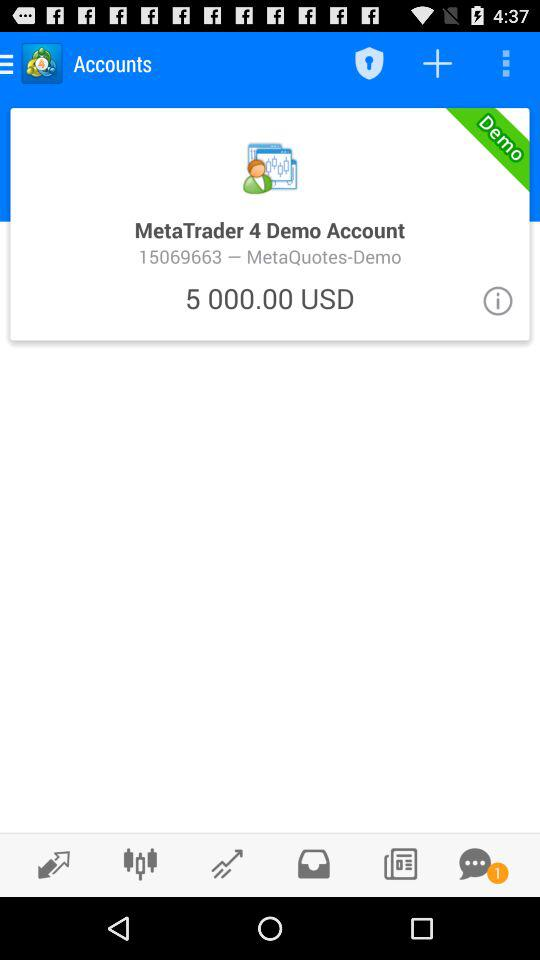How many unread chats are there? There is 1 unread chat. 